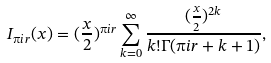<formula> <loc_0><loc_0><loc_500><loc_500>I _ { \i i r } ( x ) = ( \frac { x } { 2 } ) ^ { \i i r } \sum _ { k = 0 } ^ { \infty } \frac { ( \frac { x } { 2 } ) ^ { 2 k } } { k ! \Gamma ( \i i r + k + 1 ) } ,</formula> 